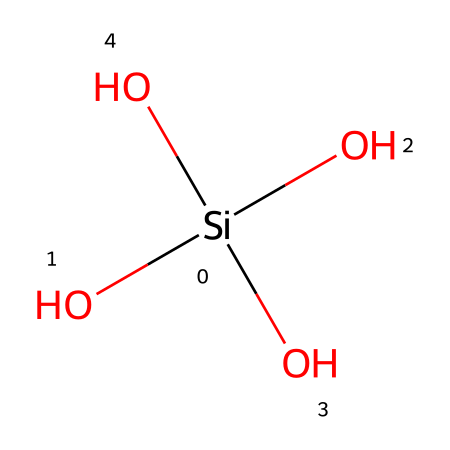What is the central atom in this chemical structure? The central atom is determined by the atom bonded to multiple oxygen atoms. In this structure, silicon is at the center, connected to four oxygen atoms.
Answer: silicon How many oxygen atoms are present in this molecule? The total number of oxygen atoms can be counted in the structure. There are four oxygen atoms surrounding the silicon atom in the structure.
Answer: four What type of bond connects silicon and oxygen in this structure? The bonds connecting silicon to oxygen are covalent bonds, which occur due to the sharing of electron pairs between these atoms.
Answer: covalent What is the molecular formula for this silica structure? The molecular formula can be derived from the number of silicon and oxygen atoms present. With one silicon atom and four oxygen atoms, the molecular formula is SiO4.
Answer: SiO4 Why is this molecule significant in the context of river sand? This molecule is significant because it constitutes the primary component of sand. The tetrahedral arrangement of silicon and oxygen gives sand its characteristic properties.
Answer: silica What geometry is exhibited by the arrangement of this silica molecule? The geometry of this molecule can be identified by the spatial arrangement of the surrounding oxygen atoms around silicon. This forms a tetrahedral shape.
Answer: tetrahedral 